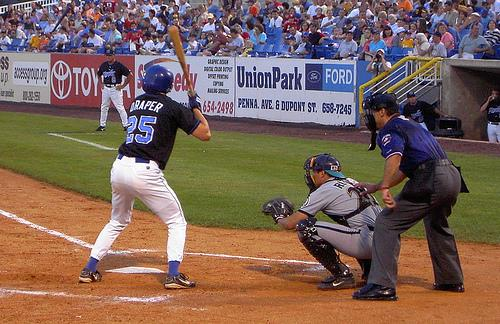Mention the leading entity in the image and what it is engaged in doing. A baseball player wearing a blue helmet and holding a wooden bat is about to hit the ball. Briefly mention the primary subject and their action in the image. A baseball player is preparing to hit the ball with a wooden bat. Identify the principal subject and explain their ongoing action in the photograph. The image concentrates on a baseball player who is about to strike the ball with a wooden baseball bat. Provide a succinct account of the key subject and their activity in the image. The image portrays a baseball player gearing up to bat using a wooden baseball bat. In a concise manner, explain the main point of interest in the image and their action. A batter in a baseball game is shown getting ready to swing at the ball with his wooden bat. Indicate who the main subject is in the image and what they are undertaking. The photograph showcases a baseball player readying himself to hit a ball with a wooden bat. Point out the key character in the picture and their performed task. A man in the image is playing baseball and preparing to hit the ball using a wooden bat. Specify the primary figure and their current activity within the photograph. In the image, a baseball player actively positions himself to hit the ball with a wooden bat. State the main focus of the image and describe its activity. The central figure, a baseball batter, gets ready to swing a wooden bat at the incoming pitch. Present a crisp description of the focal point in the image and its happening. The image features a baseball batter setting up to hit a ball with a wooden bat in hand. 